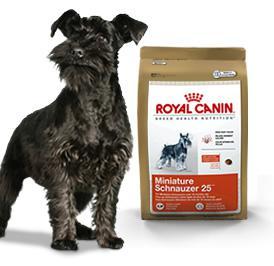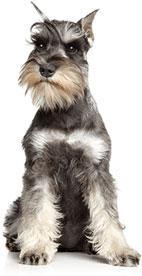The first image is the image on the left, the second image is the image on the right. Evaluate the accuracy of this statement regarding the images: "An image shows a standing schnauzer dog posed with dog food.". Is it true? Answer yes or no. Yes. The first image is the image on the left, the second image is the image on the right. Analyze the images presented: Is the assertion "The dogs are facing generally in the opposite direction" valid? Answer yes or no. No. 